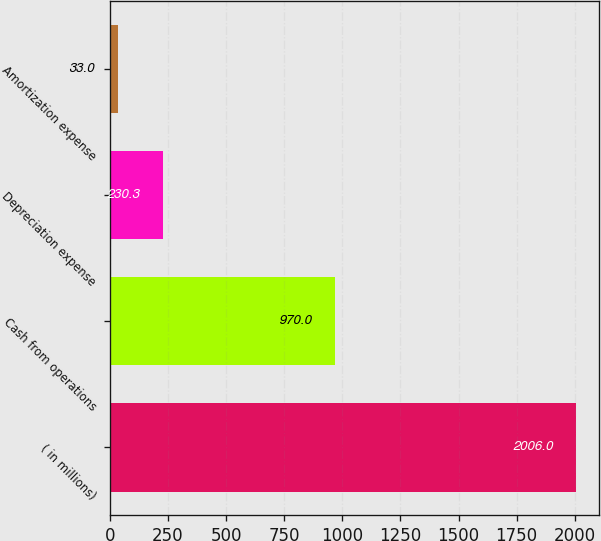<chart> <loc_0><loc_0><loc_500><loc_500><bar_chart><fcel>( in millions)<fcel>Cash from operations<fcel>Depreciation expense<fcel>Amortization expense<nl><fcel>2006<fcel>970<fcel>230.3<fcel>33<nl></chart> 